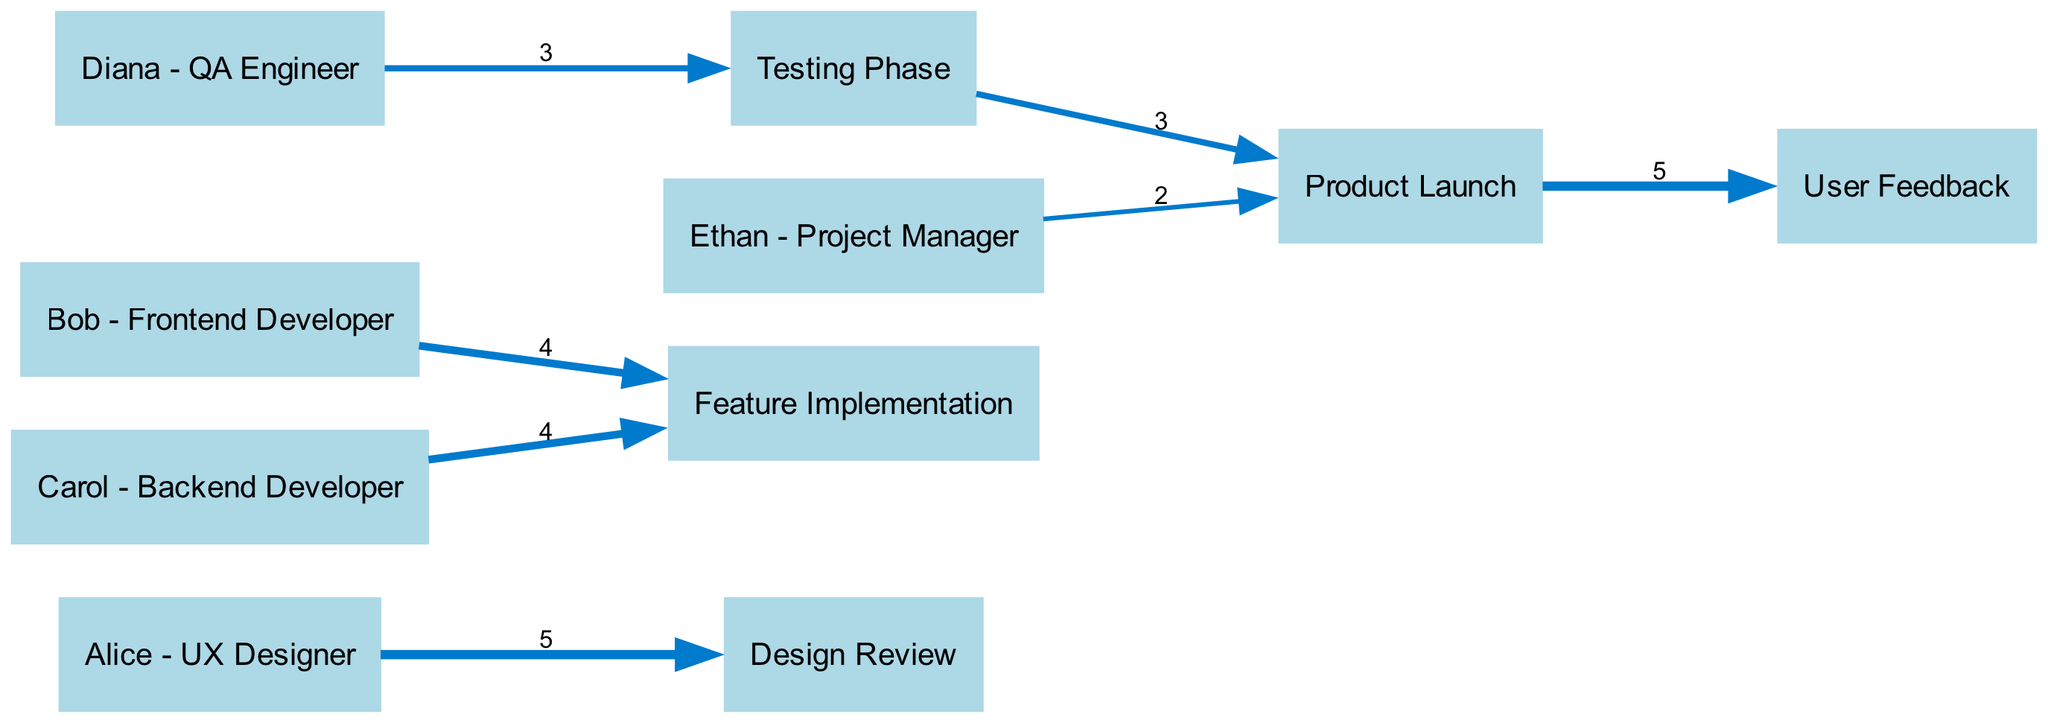What is the value linking Alice to Design Review? In the diagram, I look for the link that connects Alice to the Design Review node. The value shown on this link indicates the contribution of Alice towards the Design Review phase. The link shows a value of 5.
Answer: 5 How many total nodes are in the diagram? To find the total number of nodes, I count each unique node listed in the diagram. The nodes include Alice, Bob, Carol, Diana, Ethan, Design Review, Feature Implementation, Testing Phase, Launch, and User Feedback, totaling 10 nodes.
Answer: 10 What is the value of the edge from Testing Phase to Launch? I examine the edge that connects Testing Phase to Launch. The value on this edge indicates how many contributions or efforts led to the Launch from the Testing Phase. The edge carries a value of 3.
Answer: 3 Which team member contributed equally to Feature Implementation? I look at the links leading to the Feature Implementation node and find that both Bob and Carol contributed the same value to this phase. Bob's link shows a value of 4, and Carol's link shows the same value of 4, indicating equal contribution.
Answer: Bob and Carol What is the total value of contributions leading to User Feedback? To determine the total contributions leading to User Feedback, I look at the edges leading to this node. First, I identify that the only incoming edge is from Launch, which has a value of 5. Therefore, the total value of contributions leading to User Feedback is 5.
Answer: 5 How many contributions did Diana make in the testing phase? I look for the link that connects Diana to the Testing Phase. The value of this link indicates the number of contributions Diana made during this phase. The link shows a value of 3.
Answer: 3 What do you notice about the relationship between the Launch and User Feedback nodes? I observe the connection from the Launch node to the User Feedback node. This link represents the flow of contributions that lead to receiving User Feedback, which has a value of 5. Thus, the Launch phase seems crucial for gathering User Feedback.
Answer: Launch contributes 5 to User Feedback Which phase received the least contributions? I review the contributions to each phase by analyzing incoming edges. The Launch phase received 5 (from Testing Phase), and both Design Review and Feature Implementation had higher values. Therefore, the phase with the least contributions is the Launch, which has a value of 2.
Answer: Launch 